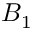Convert formula to latex. <formula><loc_0><loc_0><loc_500><loc_500>B _ { 1 }</formula> 